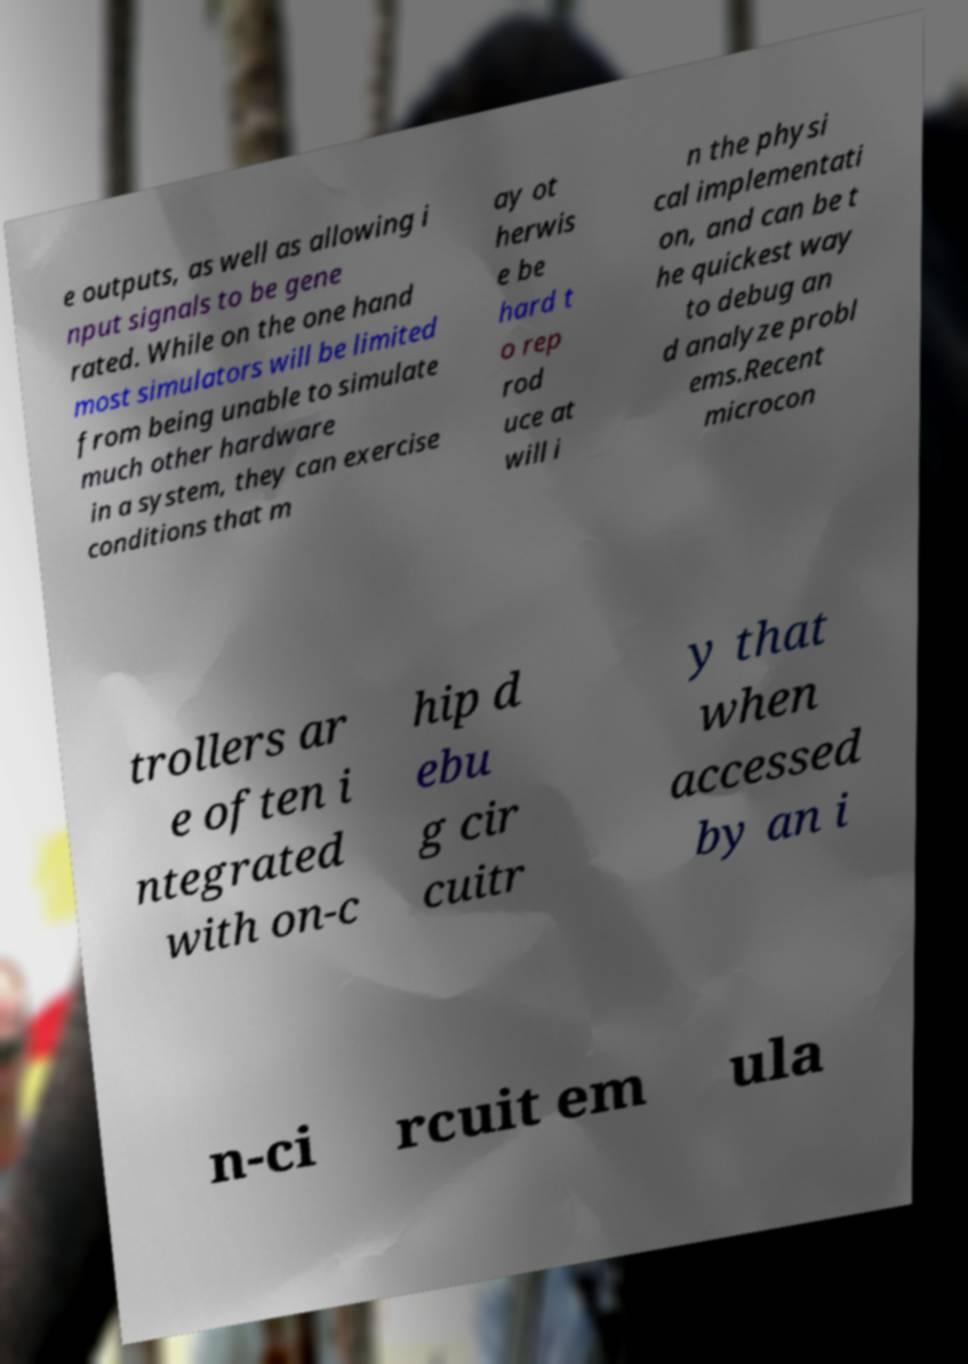For documentation purposes, I need the text within this image transcribed. Could you provide that? e outputs, as well as allowing i nput signals to be gene rated. While on the one hand most simulators will be limited from being unable to simulate much other hardware in a system, they can exercise conditions that m ay ot herwis e be hard t o rep rod uce at will i n the physi cal implementati on, and can be t he quickest way to debug an d analyze probl ems.Recent microcon trollers ar e often i ntegrated with on-c hip d ebu g cir cuitr y that when accessed by an i n-ci rcuit em ula 